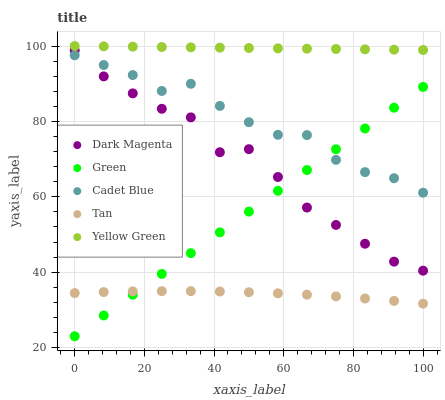Does Tan have the minimum area under the curve?
Answer yes or no. Yes. Does Yellow Green have the maximum area under the curve?
Answer yes or no. Yes. Does Cadet Blue have the minimum area under the curve?
Answer yes or no. No. Does Cadet Blue have the maximum area under the curve?
Answer yes or no. No. Is Yellow Green the smoothest?
Answer yes or no. Yes. Is Dark Magenta the roughest?
Answer yes or no. Yes. Is Cadet Blue the smoothest?
Answer yes or no. No. Is Cadet Blue the roughest?
Answer yes or no. No. Does Green have the lowest value?
Answer yes or no. Yes. Does Cadet Blue have the lowest value?
Answer yes or no. No. Does Yellow Green have the highest value?
Answer yes or no. Yes. Does Cadet Blue have the highest value?
Answer yes or no. No. Is Dark Magenta less than Yellow Green?
Answer yes or no. Yes. Is Yellow Green greater than Tan?
Answer yes or no. Yes. Does Dark Magenta intersect Cadet Blue?
Answer yes or no. Yes. Is Dark Magenta less than Cadet Blue?
Answer yes or no. No. Is Dark Magenta greater than Cadet Blue?
Answer yes or no. No. Does Dark Magenta intersect Yellow Green?
Answer yes or no. No. 